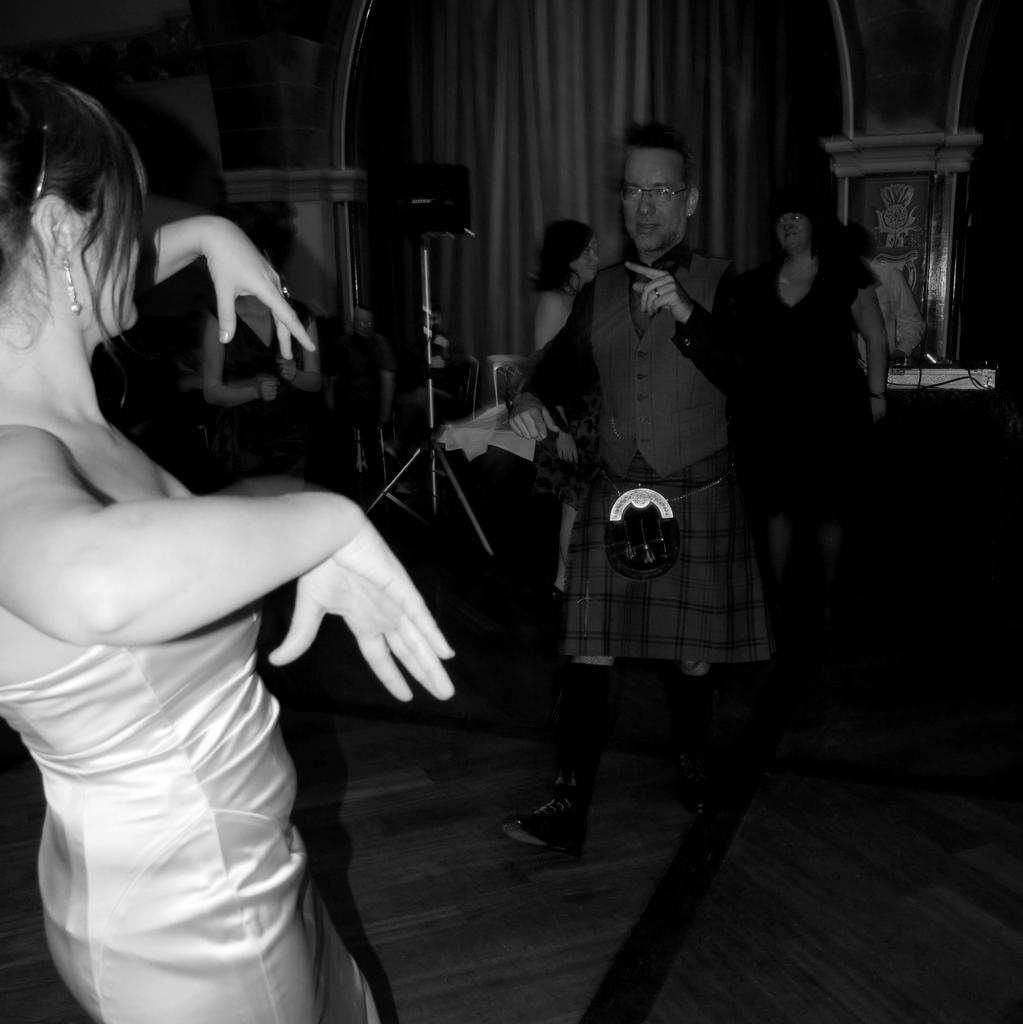How would you summarize this image in a sentence or two? This is a black and white image. On the left side there is a woman dancing by looking at the man who is in front of her. In the background there are two women standing. There are a metal stand, chairs and few objects placed on the floor. At the top of the image there are two pillars. Behind there is a curtain. 